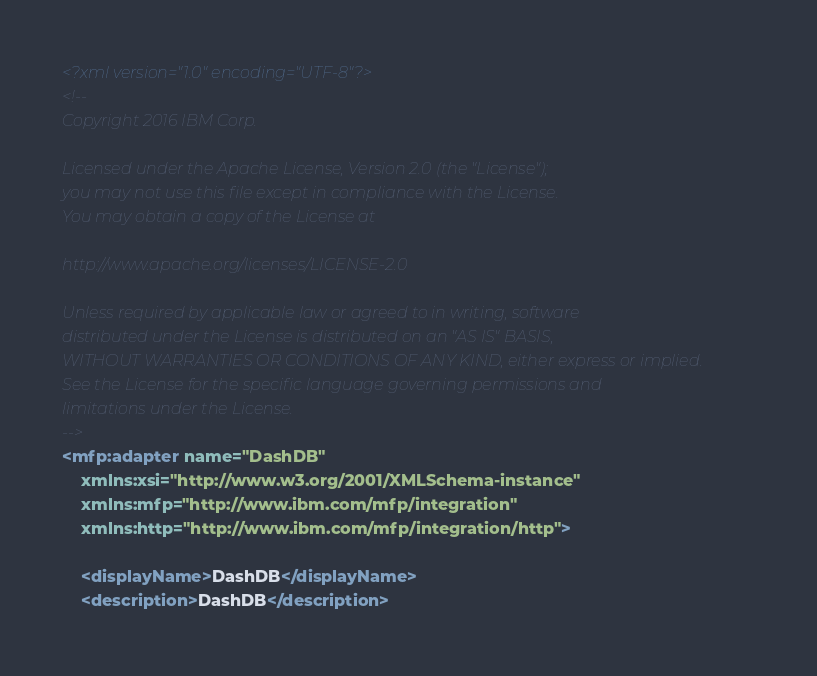Convert code to text. <code><loc_0><loc_0><loc_500><loc_500><_XML_><?xml version="1.0" encoding="UTF-8"?>
<!--
Copyright 2016 IBM Corp.

Licensed under the Apache License, Version 2.0 (the "License");
you may not use this file except in compliance with the License.
You may obtain a copy of the License at

http://www.apache.org/licenses/LICENSE-2.0

Unless required by applicable law or agreed to in writing, software
distributed under the License is distributed on an "AS IS" BASIS,
WITHOUT WARRANTIES OR CONDITIONS OF ANY KIND, either express or implied.
See the License for the specific language governing permissions and
limitations under the License.
-->
<mfp:adapter name="DashDB"
	xmlns:xsi="http://www.w3.org/2001/XMLSchema-instance"
	xmlns:mfp="http://www.ibm.com/mfp/integration"
	xmlns:http="http://www.ibm.com/mfp/integration/http">

	<displayName>DashDB</displayName>
	<description>DashDB</description>
</code> 